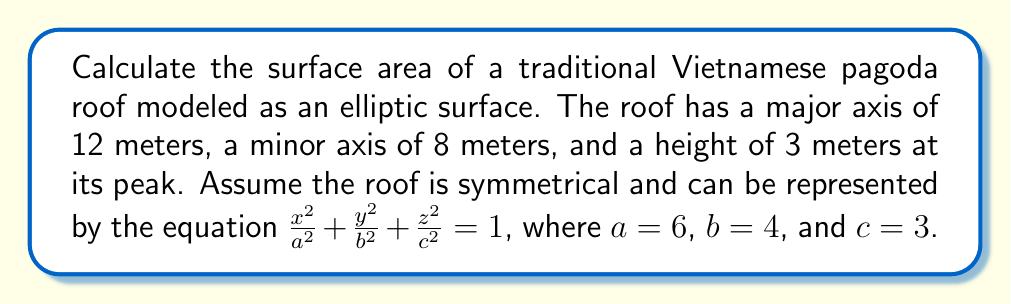What is the answer to this math problem? To calculate the surface area of the elliptic roof, we'll follow these steps:

1) The surface area of an ellipsoid is given by the formula:

   $$A \approx 4\pi \left(\frac{(ab)^p + (ac)^p + (bc)^p}{3}\right)^{\frac{1}{p}}$$

   where $p \approx 1.6075$

2) Substitute the values:
   $a = 6$, $b = 4$, $c = 3$

3) Calculate each term inside the parentheses:
   $$(ab)^p = (6 \cdot 4)^{1.6075} \approx 154.51$$
   $$(ac)^p = (6 \cdot 3)^{1.6075} \approx 95.76$$
   $$(bc)^p = (4 \cdot 3)^{1.6075} \approx 52.50$$

4) Sum these terms and divide by 3:
   $$\frac{154.51 + 95.76 + 52.50}{3} \approx 100.92$$

5) Take this result to the power of $\frac{1}{p}$:
   $$100.92^{\frac{1}{1.6075}} \approx 18.95$$

6) Multiply by $4\pi$:
   $$4\pi \cdot 18.95 \approx 237.85$$

7) Since we only need the upper half of the ellipsoid for the roof, divide the result by 2:
   $$\frac{237.85}{2} \approx 118.93$$

Therefore, the surface area of the roof is approximately 118.93 square meters.
Answer: 118.93 m² 